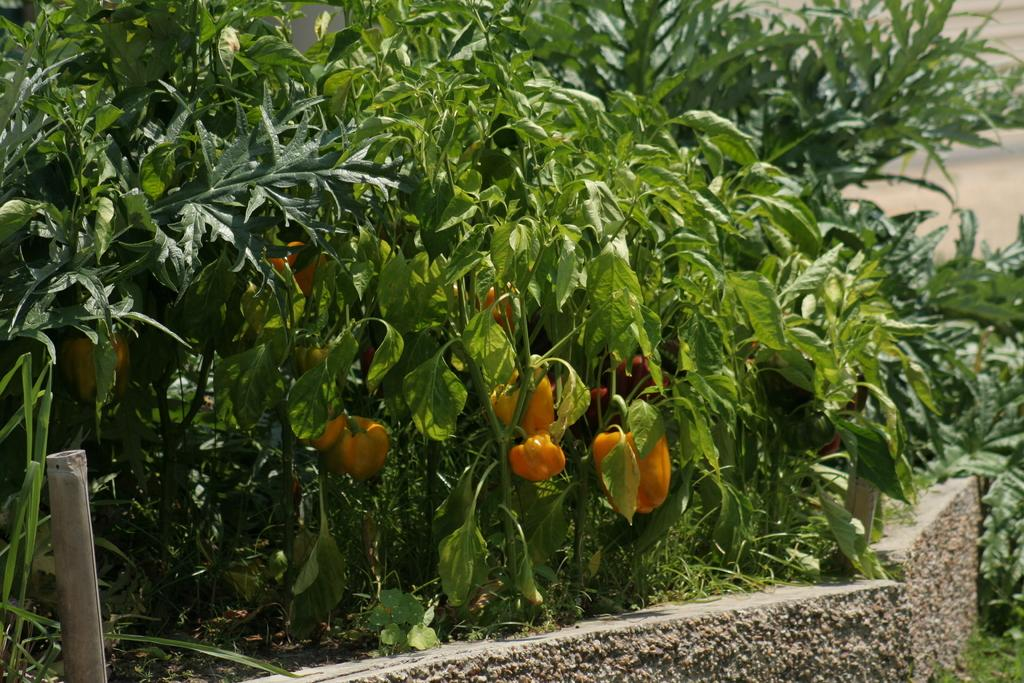What type of vegetable is present in the image? There are capsicums in the image. What else can be seen in the image besides the capsicums? There are plants in the image. Where is the iron rod located in the image? The iron rod is on the left side of the image. What is present at the bottom of the image? There are stones at the bottom of the image. Can you describe the waves in the image? There are no waves present in the image. 